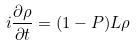<formula> <loc_0><loc_0><loc_500><loc_500>i \frac { \partial \rho } { \partial t } = ( { 1 } - { P } ) { L } \rho</formula> 